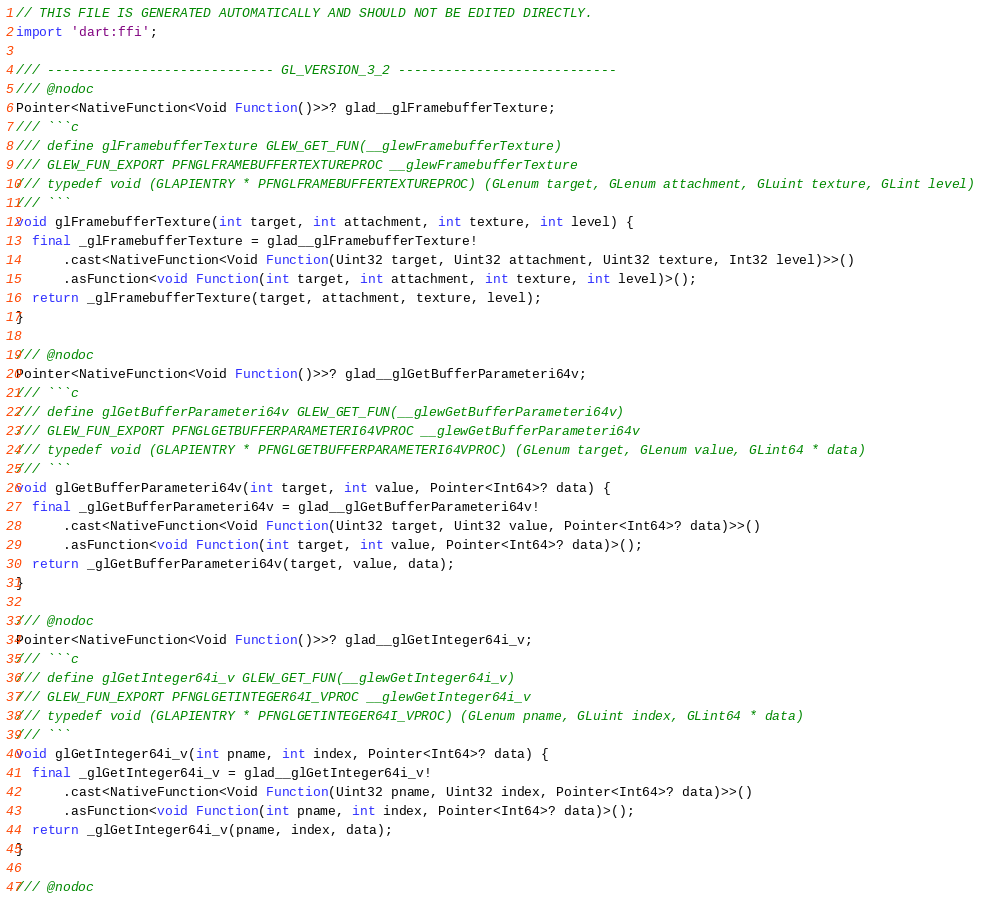Convert code to text. <code><loc_0><loc_0><loc_500><loc_500><_Dart_>// THIS FILE IS GENERATED AUTOMATICALLY AND SHOULD NOT BE EDITED DIRECTLY.
import 'dart:ffi';

/// ----------------------------- GL_VERSION_3_2 ----------------------------
/// @nodoc
Pointer<NativeFunction<Void Function()>>? glad__glFramebufferTexture;
/// ```c
/// define glFramebufferTexture GLEW_GET_FUN(__glewFramebufferTexture)
/// GLEW_FUN_EXPORT PFNGLFRAMEBUFFERTEXTUREPROC __glewFramebufferTexture
/// typedef void (GLAPIENTRY * PFNGLFRAMEBUFFERTEXTUREPROC) (GLenum target, GLenum attachment, GLuint texture, GLint level)
/// ```
void glFramebufferTexture(int target, int attachment, int texture, int level) {
  final _glFramebufferTexture = glad__glFramebufferTexture!
      .cast<NativeFunction<Void Function(Uint32 target, Uint32 attachment, Uint32 texture, Int32 level)>>()
      .asFunction<void Function(int target, int attachment, int texture, int level)>();
  return _glFramebufferTexture(target, attachment, texture, level);
}

/// @nodoc
Pointer<NativeFunction<Void Function()>>? glad__glGetBufferParameteri64v;
/// ```c
/// define glGetBufferParameteri64v GLEW_GET_FUN(__glewGetBufferParameteri64v)
/// GLEW_FUN_EXPORT PFNGLGETBUFFERPARAMETERI64VPROC __glewGetBufferParameteri64v
/// typedef void (GLAPIENTRY * PFNGLGETBUFFERPARAMETERI64VPROC) (GLenum target, GLenum value, GLint64 * data)
/// ```
void glGetBufferParameteri64v(int target, int value, Pointer<Int64>? data) {
  final _glGetBufferParameteri64v = glad__glGetBufferParameteri64v!
      .cast<NativeFunction<Void Function(Uint32 target, Uint32 value, Pointer<Int64>? data)>>()
      .asFunction<void Function(int target, int value, Pointer<Int64>? data)>();
  return _glGetBufferParameteri64v(target, value, data);
}

/// @nodoc
Pointer<NativeFunction<Void Function()>>? glad__glGetInteger64i_v;
/// ```c
/// define glGetInteger64i_v GLEW_GET_FUN(__glewGetInteger64i_v)
/// GLEW_FUN_EXPORT PFNGLGETINTEGER64I_VPROC __glewGetInteger64i_v
/// typedef void (GLAPIENTRY * PFNGLGETINTEGER64I_VPROC) (GLenum pname, GLuint index, GLint64 * data)
/// ```
void glGetInteger64i_v(int pname, int index, Pointer<Int64>? data) {
  final _glGetInteger64i_v = glad__glGetInteger64i_v!
      .cast<NativeFunction<Void Function(Uint32 pname, Uint32 index, Pointer<Int64>? data)>>()
      .asFunction<void Function(int pname, int index, Pointer<Int64>? data)>();
  return _glGetInteger64i_v(pname, index, data);
}

/// @nodoc</code> 